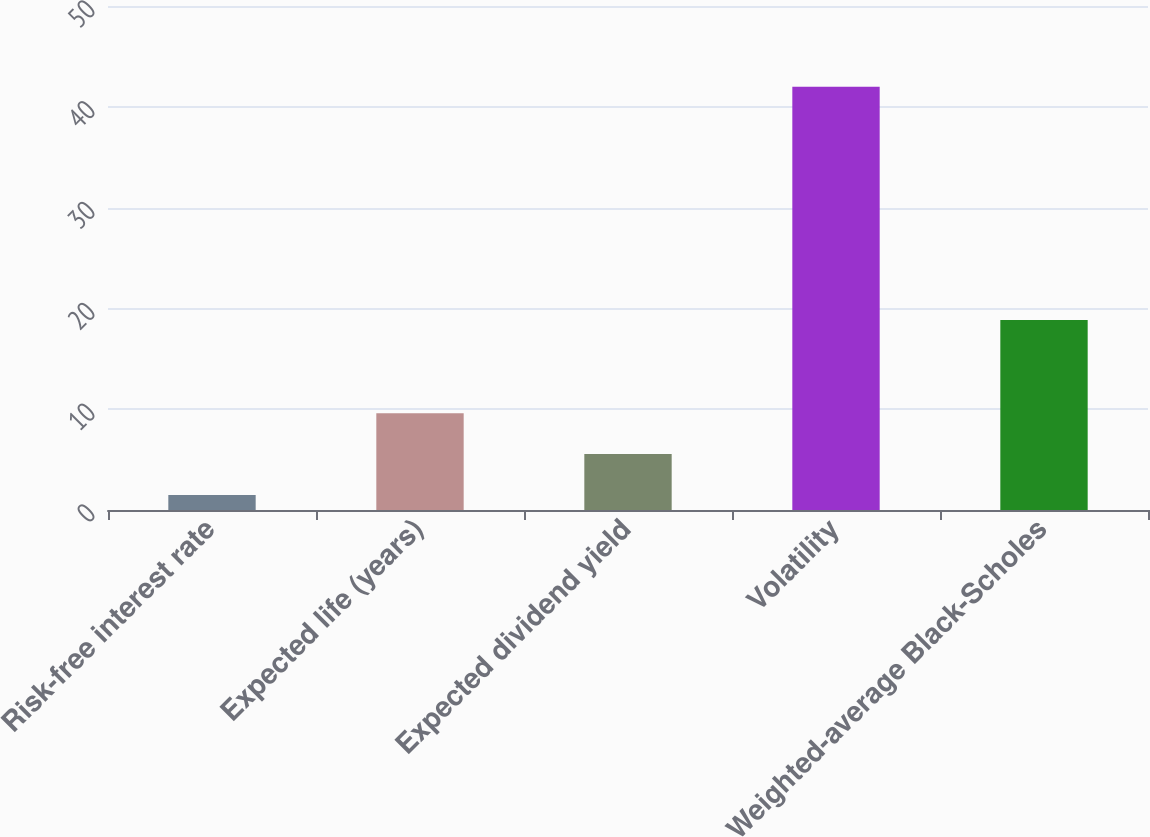Convert chart to OTSL. <chart><loc_0><loc_0><loc_500><loc_500><bar_chart><fcel>Risk-free interest rate<fcel>Expected life (years)<fcel>Expected dividend yield<fcel>Volatility<fcel>Weighted-average Black-Scholes<nl><fcel>1.5<fcel>9.6<fcel>5.55<fcel>42<fcel>18.85<nl></chart> 